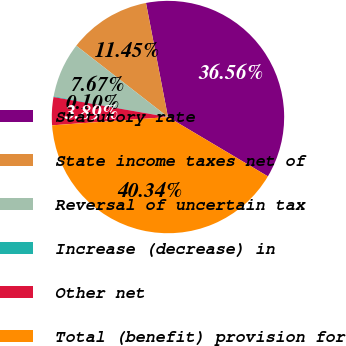Convert chart. <chart><loc_0><loc_0><loc_500><loc_500><pie_chart><fcel>Statutory rate<fcel>State income taxes net of<fcel>Reversal of uncertain tax<fcel>Increase (decrease) in<fcel>Other net<fcel>Total (benefit) provision for<nl><fcel>36.56%<fcel>11.45%<fcel>7.67%<fcel>0.1%<fcel>3.89%<fcel>40.34%<nl></chart> 